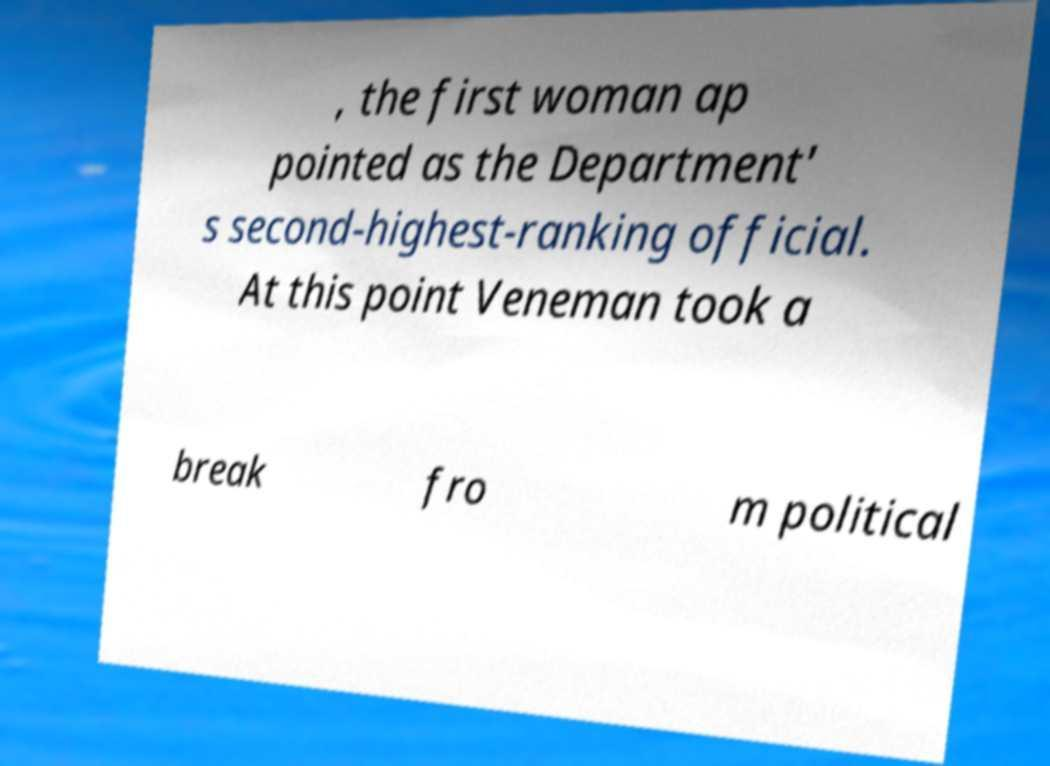Can you read and provide the text displayed in the image?This photo seems to have some interesting text. Can you extract and type it out for me? , the first woman ap pointed as the Department' s second-highest-ranking official. At this point Veneman took a break fro m political 